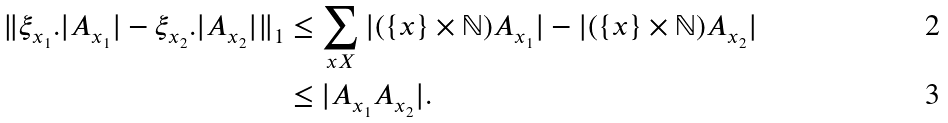Convert formula to latex. <formula><loc_0><loc_0><loc_500><loc_500>\| \xi _ { x _ { 1 } } . | A _ { x _ { 1 } } | - \xi _ { x _ { 2 } } . | A _ { x _ { 2 } } | \| _ { 1 } & \leq \sum _ { x X } | ( \{ x \} \times \mathbb { N } ) A _ { x _ { 1 } } | - | ( \{ x \} \times \mathbb { N } ) A _ { x _ { 2 } } | \\ & \leq | A _ { x _ { 1 } } A _ { x _ { 2 } } | .</formula> 